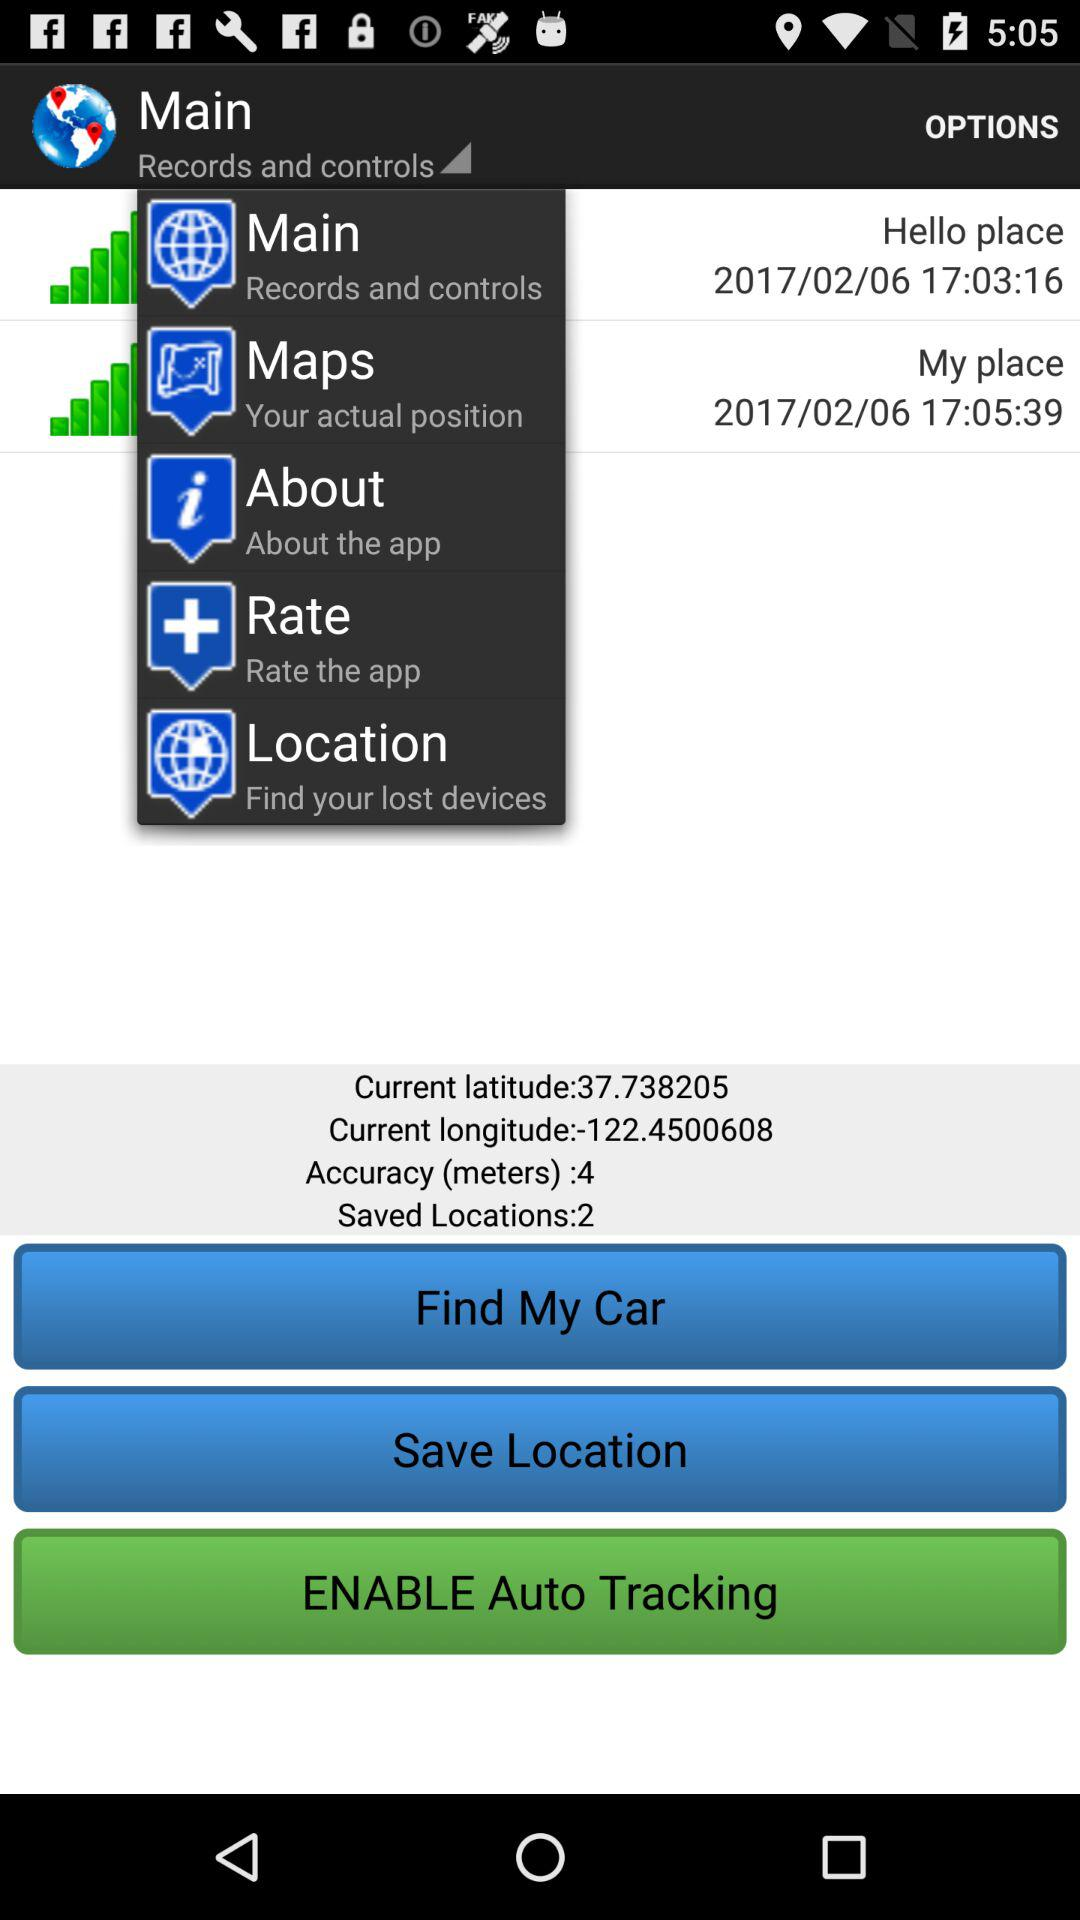What is the current longitude? The current longitude is -122.4500608. 